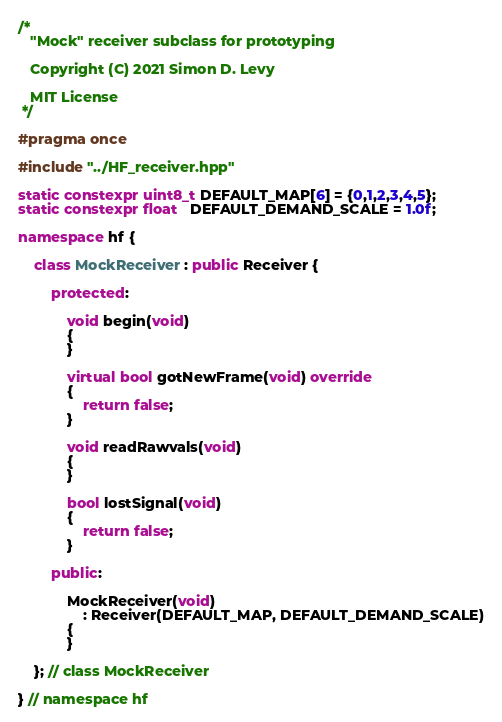<code> <loc_0><loc_0><loc_500><loc_500><_C++_>/*
   "Mock" receiver subclass for prototyping

   Copyright (C) 2021 Simon D. Levy

   MIT License
 */

#pragma once

#include "../HF_receiver.hpp"

static constexpr uint8_t DEFAULT_MAP[6] = {0,1,2,3,4,5};
static constexpr float   DEFAULT_DEMAND_SCALE = 1.0f;

namespace hf {

    class MockReceiver : public Receiver {

        protected:

            void begin(void)
            {
            }

            virtual bool gotNewFrame(void) override
            {
                return false;
            }

            void readRawvals(void)
            {
            }

            bool lostSignal(void)
            {
                return false;
            }

        public:

            MockReceiver(void) 
                : Receiver(DEFAULT_MAP, DEFAULT_DEMAND_SCALE)
            { 
            }

    }; // class MockReceiver

} // namespace hf
</code> 